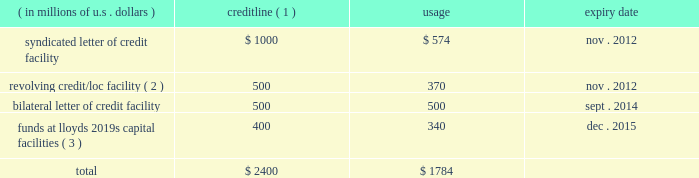Credit facilities as our bermuda subsidiaries are not admitted insurers and reinsurers in the u.s. , the terms of certain u.s .
Insurance and reinsurance contracts require them to provide collateral , which can be in the form of locs .
In addition , ace global markets is required to satisfy certain u.s .
Regulatory trust fund requirements which can be met by the issuance of locs .
Locs may also be used for general corporate purposes and to provide underwriting capacity as funds at lloyd 2019s .
The table shows our main credit facilities by credit line , usage , and expiry date at december 31 , 2010 .
( in millions of u.s .
Dollars ) credit line ( 1 ) usage expiry date .
( 1 ) certain facilities are guaranteed by operating subsidiaries and/or ace limited .
( 2 ) may also be used for locs .
( 3 ) supports ace global markets underwriting capacity for lloyd 2019s syndicate 2488 ( see discussion below ) .
In november 2010 , we entered into four letter of credit facility agreements which collectively permit the issuance of up to $ 400 million of letters of credit .
We expect that most of the locs issued under the loc agreements will be used to support the ongoing funds at lloyd 2019s requirements of syndicate 2488 , but locs may also be used for other general corporate purposes .
It is anticipated that our commercial facilities will be renewed on expiry but such renewals are subject to the availability of credit from banks utilized by ace .
In the event that such credit support is insufficient , we could be required to provide alter- native security to clients .
This could take the form of additional insurance trusts supported by our investment portfolio or funds withheld using our cash resources .
The value of letters of credit required is driven by , among other things , statutory liabilities reported by variable annuity guarantee reinsurance clients , loss development of existing reserves , the payment pattern of such reserves , the expansion of business , and loss experience of such business .
The facilities in the table above require that we maintain certain covenants , all of which have been met at december 31 , 2010 .
These covenants include : ( i ) maintenance of a minimum consolidated net worth in an amount not less than the 201cminimum amount 201d .
For the purpose of this calculation , the minimum amount is an amount equal to the sum of the base amount ( currently $ 13.8 billion ) plus 25 percent of consolidated net income for each fiscal quarter , ending after the date on which the current base amount became effective , plus 50 percent of any increase in consolidated net worth during the same period , attributable to the issuance of common and preferred shares .
The minimum amount is subject to an annual reset provision .
( ii ) maintenance of a maximum debt to total capitalization ratio of not greater than 0.35 to 1 .
Under this covenant , debt does not include trust preferred securities or mezzanine equity , except where the ratio of the sum of trust preferred securities and mezzanine equity to total capitalization is greater than 15 percent .
In this circumstance , the amount greater than 15 percent would be included in the debt to total capitalization ratio .
At december 31 , 2010 , ( a ) the minimum consolidated net worth requirement under the covenant described in ( i ) above was $ 14.5 billion and our actual consolidated net worth as calculated under that covenant was $ 21.6 billion and ( b ) our ratio of debt to total capitalization was 0.167 to 1 , which is below the maximum debt to total capitalization ratio of 0.35 to 1 as described in ( ii ) above .
Our failure to comply with the covenants under any credit facility would , subject to grace periods in the case of certain covenants , result in an event of default .
This could require us to repay any outstanding borrowings or to cash collateralize locs under such facility .
A failure by ace limited ( or any of its subsidiaries ) to pay an obligation due for an amount exceeding $ 50 million would result in an event of default under all of the facilities described above .
Ratings ace limited and its subsidiaries are assigned debt and financial strength ( insurance ) ratings from internationally recognized rating agencies , including s&p , a.m .
Best , moody 2019s investors service , and fitch .
The ratings issued on our companies by these agencies are announced publicly and are available directly from the agencies .
Our internet site , www.acegroup.com .
What portion of the total credit line limits is from syndicated letter of credit facility? 
Computations: (1000 / 2400)
Answer: 0.41667. 